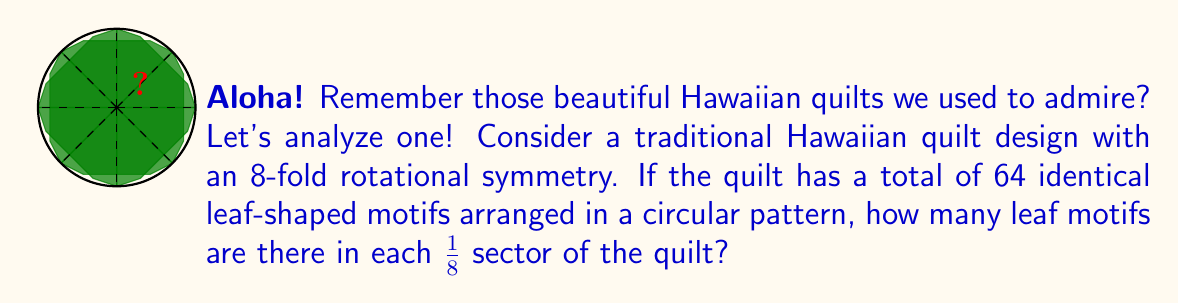What is the answer to this math problem? Let's approach this step-by-step:

1) First, we need to understand what 8-fold rotational symmetry means. It implies that the design can be rotated 8 times (45° each) and still look the same.

2) The quilt is divided into 8 equal sectors due to this symmetry. We can represent this mathematically:

   $\text{Total sectors} = 8$

3) We're given that there are 64 identical leaf motifs in total. Let's call the number of leaf motifs in each sector $x$. We can set up an equation:

   $\text{Total leaf motifs} = \text{Number of sectors} \times \text{Leaf motifs per sector}$
   $64 = 8 \times x$

4) Now we can solve for $x$:

   $x = \frac{64}{8} = 8$

Therefore, there are 8 leaf motifs in each $\frac{1}{8}$ sector of the quilt.
Answer: 8 leaf motifs 